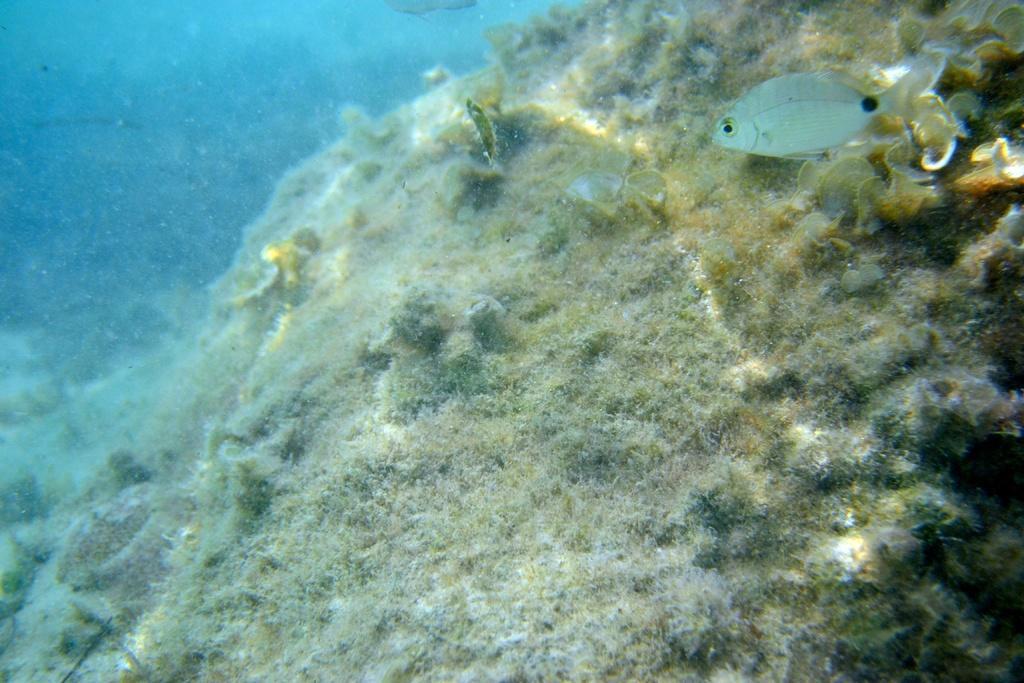In one or two sentences, can you explain what this image depicts? In this image we can see a fish in the water. Here we can see the marine plants. This part of the image is in blue color. 